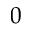Convert formula to latex. <formula><loc_0><loc_0><loc_500><loc_500>0</formula> 